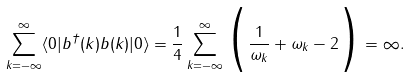<formula> <loc_0><loc_0><loc_500><loc_500>\sum _ { k = - \infty } ^ { \infty } \langle 0 | b ^ { \dagger } ( k ) b ( k ) | 0 \rangle = \frac { 1 } { 4 } \sum _ { k = - \infty } ^ { \infty } \Big { ( } \frac { 1 } { \omega _ { k } } + \omega _ { k } - 2 \Big { ) } = \infty .</formula> 